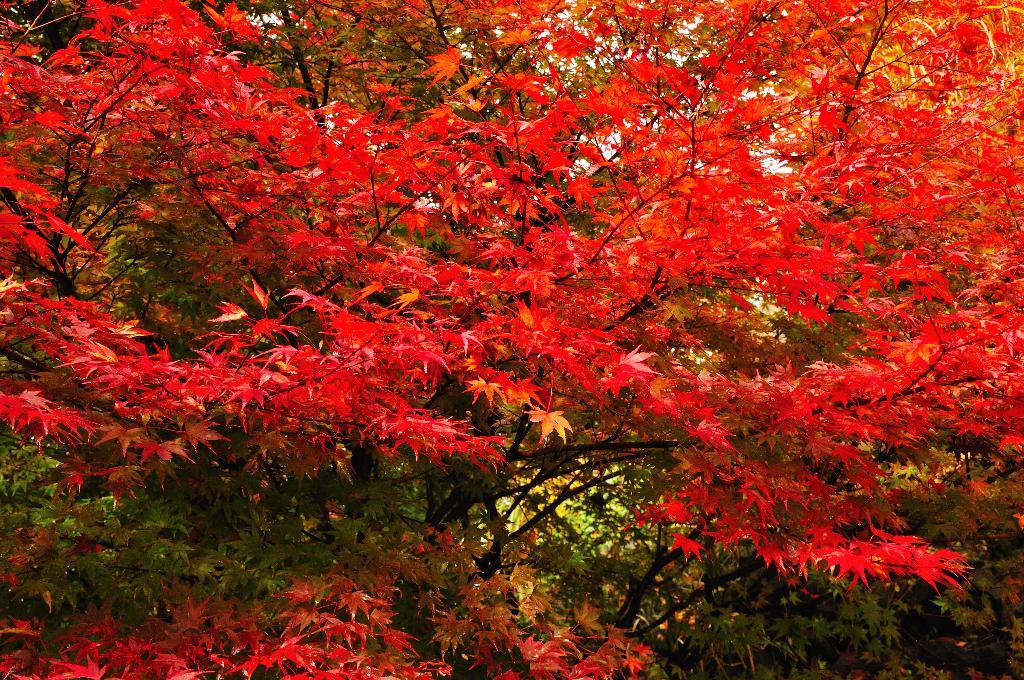What type of vegetation can be seen in the image? There are plants and trees in the image. Can you describe the plants and trees in the image? The image shows plants and trees, but specific details about their appearance cannot be determined from the provided facts. What type of sail can be seen on the pear in the image? There is no sail or pear present in the image; it only features plants and trees. 